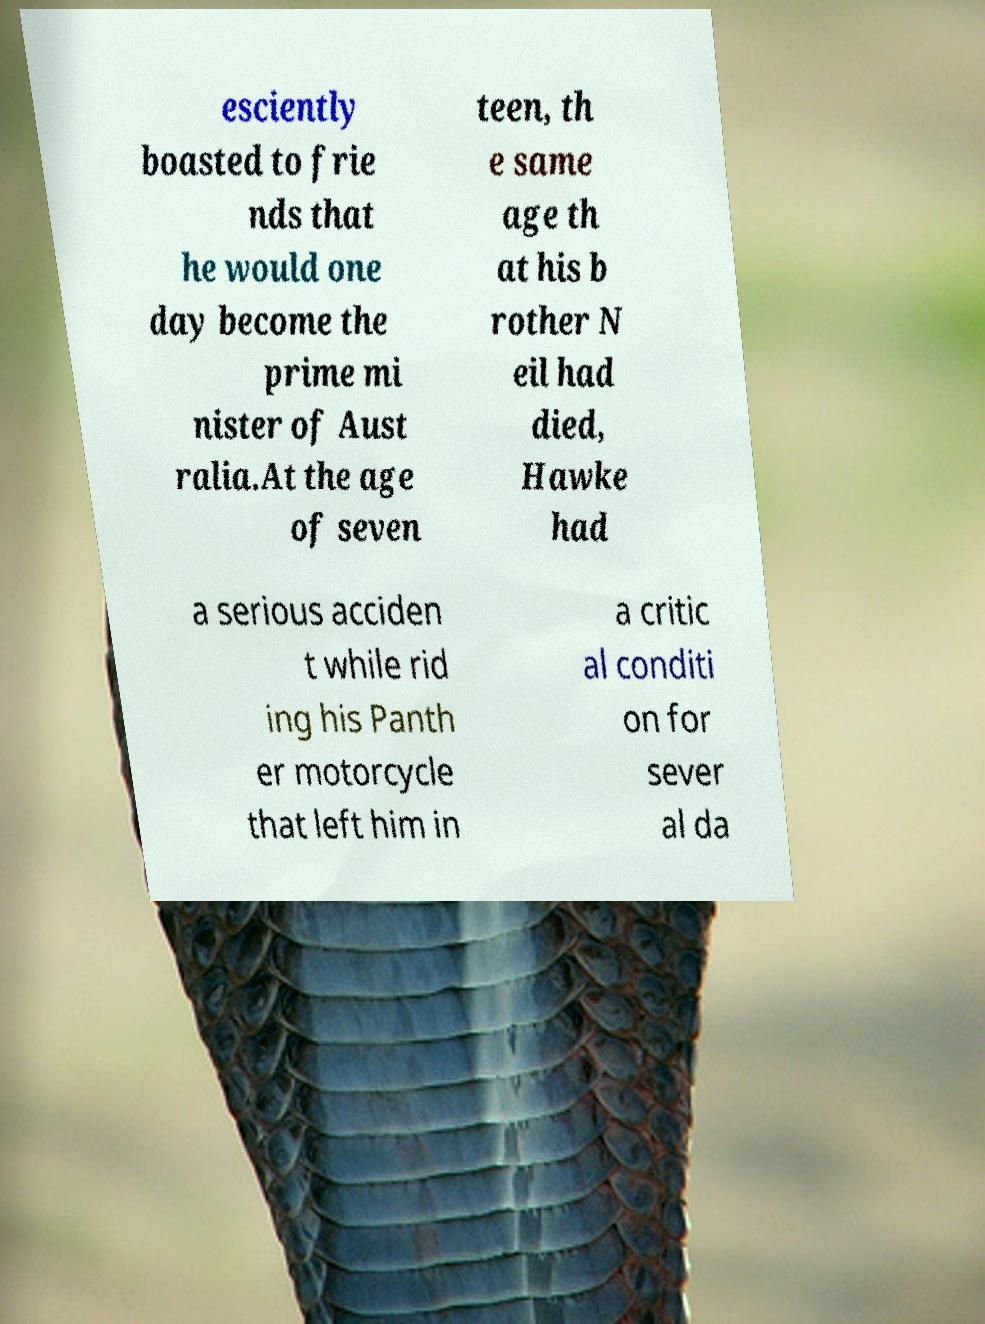There's text embedded in this image that I need extracted. Can you transcribe it verbatim? esciently boasted to frie nds that he would one day become the prime mi nister of Aust ralia.At the age of seven teen, th e same age th at his b rother N eil had died, Hawke had a serious acciden t while rid ing his Panth er motorcycle that left him in a critic al conditi on for sever al da 